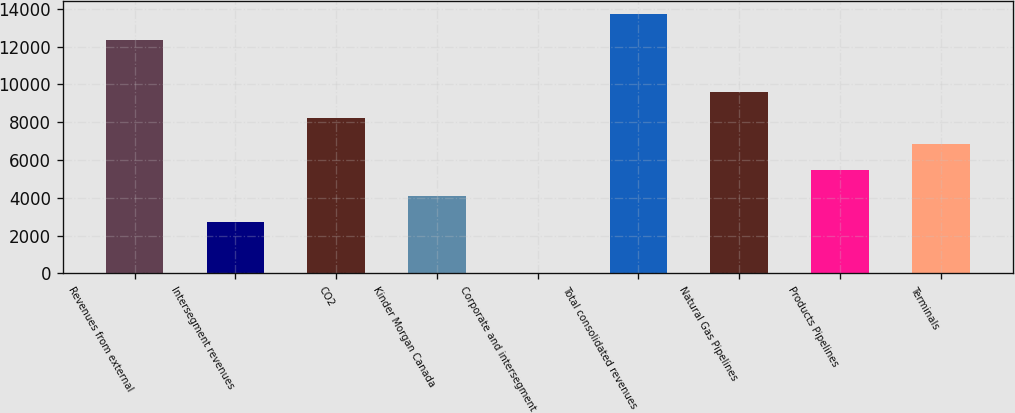Convert chart to OTSL. <chart><loc_0><loc_0><loc_500><loc_500><bar_chart><fcel>Revenues from external<fcel>Intersegment revenues<fcel>CO2<fcel>Kinder Morgan Canada<fcel>Corporate and intersegment<fcel>Total consolidated revenues<fcel>Natural Gas Pipelines<fcel>Products Pipelines<fcel>Terminals<nl><fcel>12335.1<fcel>2745.8<fcel>8225.4<fcel>4115.7<fcel>6<fcel>13705<fcel>9595.3<fcel>5485.6<fcel>6855.5<nl></chart> 